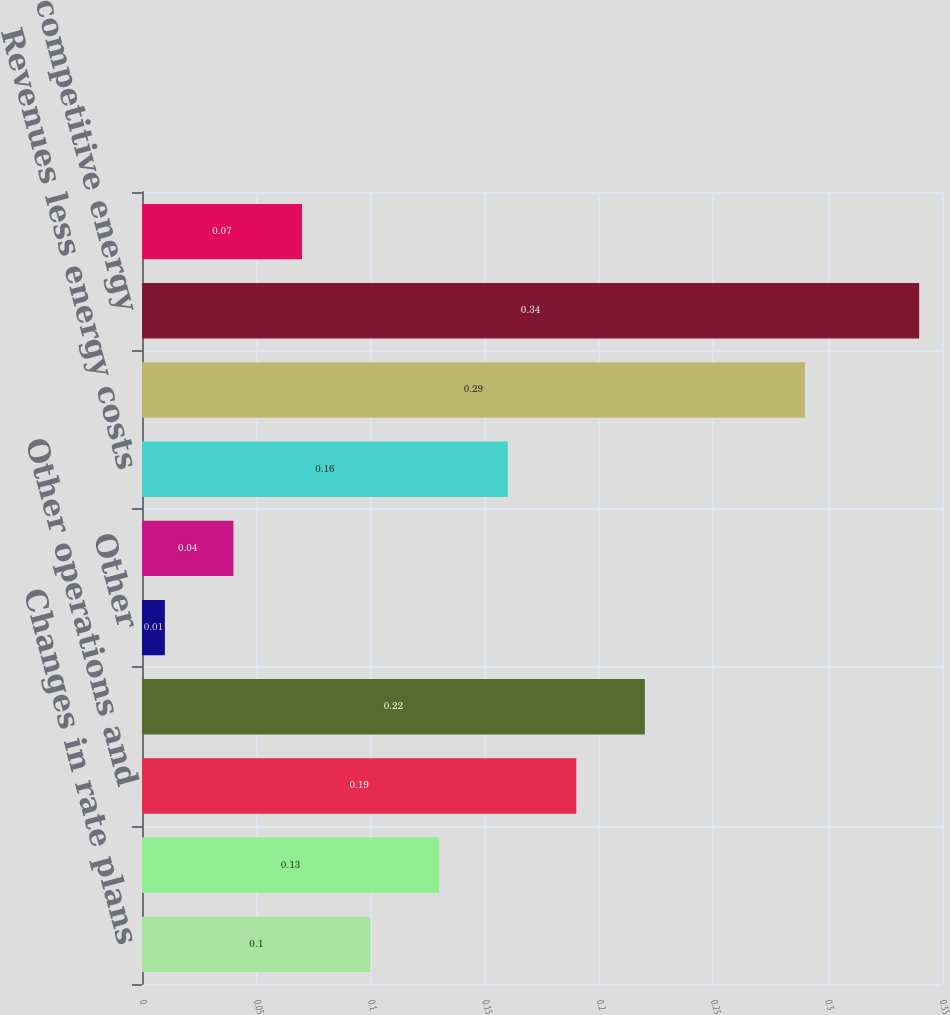Convert chart to OTSL. <chart><loc_0><loc_0><loc_500><loc_500><bar_chart><fcel>Changes in rate plans<fcel>Weather impact on steam<fcel>Other operations and<fcel>Depreciation and amortization<fcel>Other<fcel>Total CECONY<fcel>Revenues less energy costs<fcel>Net interest expense<fcel>Total competitive energy<fcel>Other including parent company<nl><fcel>0.1<fcel>0.13<fcel>0.19<fcel>0.22<fcel>0.01<fcel>0.04<fcel>0.16<fcel>0.29<fcel>0.34<fcel>0.07<nl></chart> 